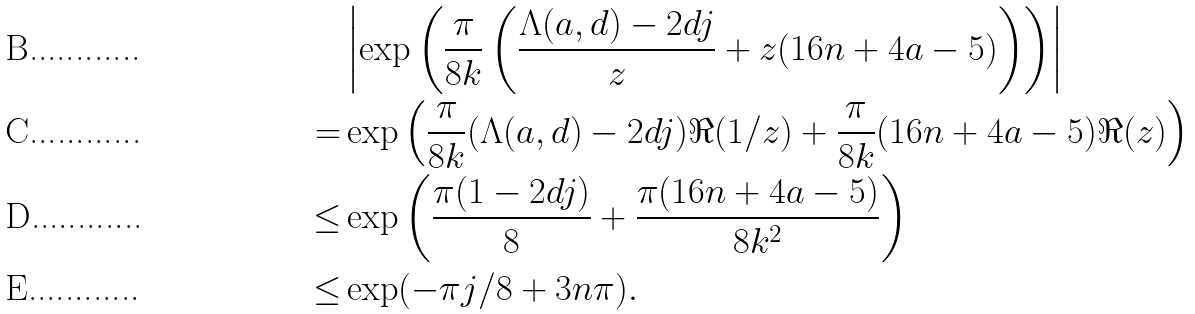<formula> <loc_0><loc_0><loc_500><loc_500>& \left | \exp \left ( \frac { \pi } { 8 k } \left ( \frac { \Lambda ( a , d ) - 2 d j } { z } + z ( 1 6 n + 4 a - 5 ) \right ) \right ) \right | \\ = & \exp \left ( \frac { \pi } { 8 k } ( \Lambda ( a , d ) - 2 d j ) \Re ( 1 / z ) + \frac { \pi } { 8 k } ( 1 6 n + 4 a - 5 ) \Re ( z ) \right ) \\ \leq & \exp \left ( \frac { \pi ( 1 - 2 d j ) } { 8 } + \frac { \pi ( 1 6 n + 4 a - 5 ) } { 8 k ^ { 2 } } \right ) \\ \leq & \exp ( - \pi j / 8 + 3 n \pi ) .</formula> 